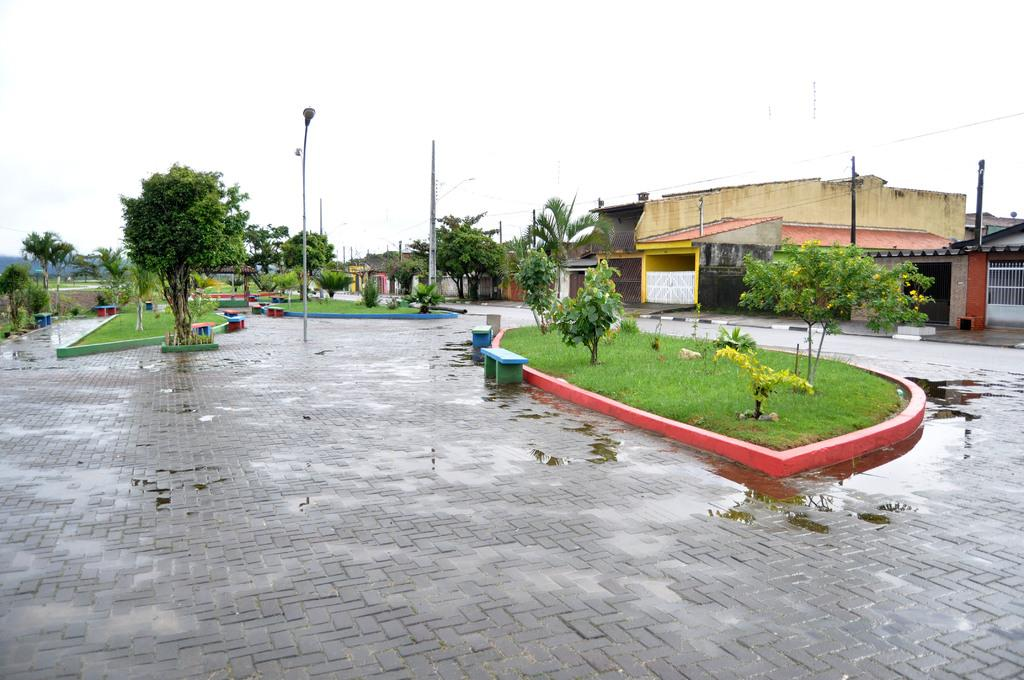What type of structures can be seen in the image? There are buildings in the image. What are the vertical objects with signs or lights on them in the image? Street poles are present in the image. What are the objects that provide illumination at night in the image? Street lights are visible in the image. What type of wires are present in the image? Electric cables are in the image. What type of vegetation is present in the image? Trees are present in the image. What type of seating is visible in the image? Benches are visible in the image. What type of surface is visible under the feet in the image? The floor is visible in the image. What type of liquid is present in the image? There is water in the image. What type of cooking appliance is present in the image? A grill is present in the image. What type of natural landform is visible in the image? Hills are visible in the image. What part of the natural environment is visible in the image? The sky is visible in the image. Where is the clover growing in the image? There is no clover present in the image. What type of uncle is sitting on the bench in the image? There is no uncle present in the image. What type of stick is being used to stir the water in the image? There is no stick present in the image, and the water is not being stirred. 